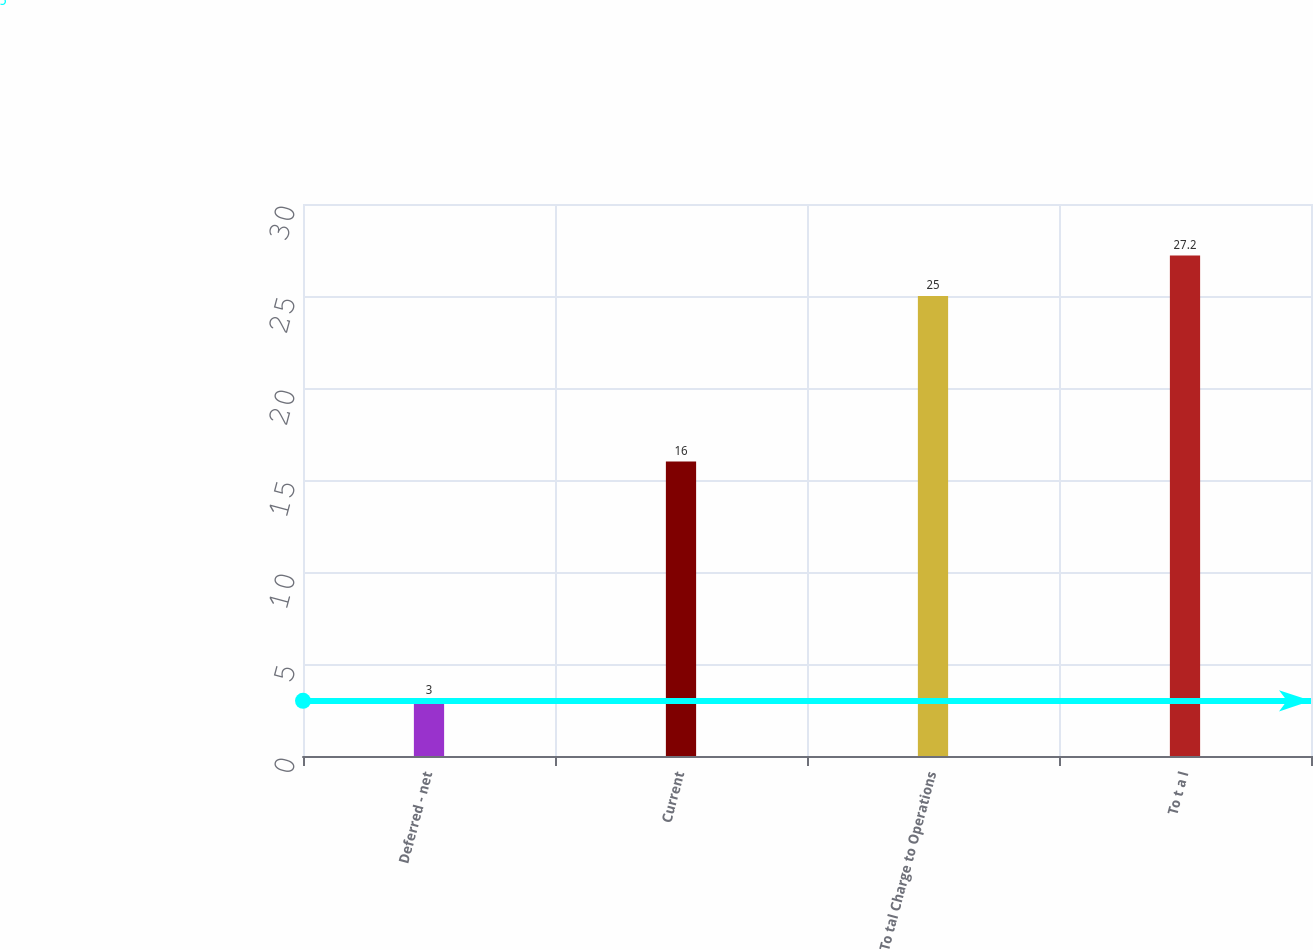Convert chart. <chart><loc_0><loc_0><loc_500><loc_500><bar_chart><fcel>Deferred - net<fcel>Current<fcel>To tal Charge to Operations<fcel>To t a l<nl><fcel>3<fcel>16<fcel>25<fcel>27.2<nl></chart> 